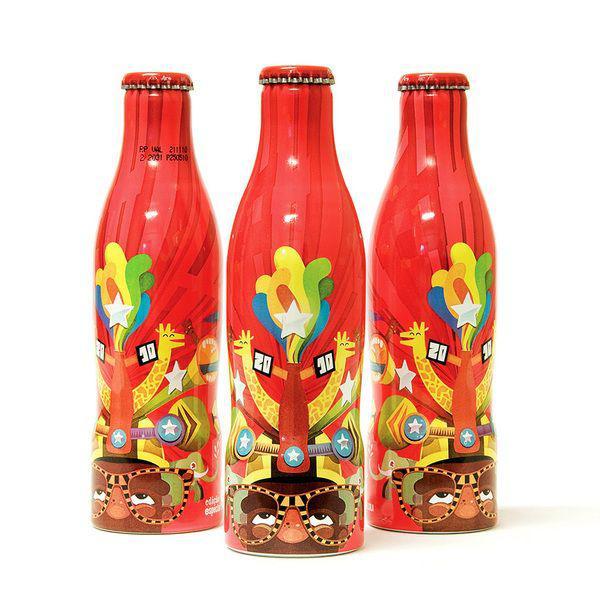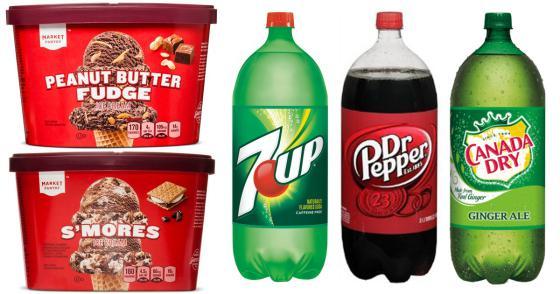The first image is the image on the left, the second image is the image on the right. For the images displayed, is the sentence "The left image includes at least three metallic-looking, multicolored bottles with red caps in a row, with the middle bottle slightly forward." factually correct? Answer yes or no. Yes. The first image is the image on the left, the second image is the image on the right. Given the left and right images, does the statement "In one of the images, all of the bottles are Coca-Cola bottles." hold true? Answer yes or no. No. 